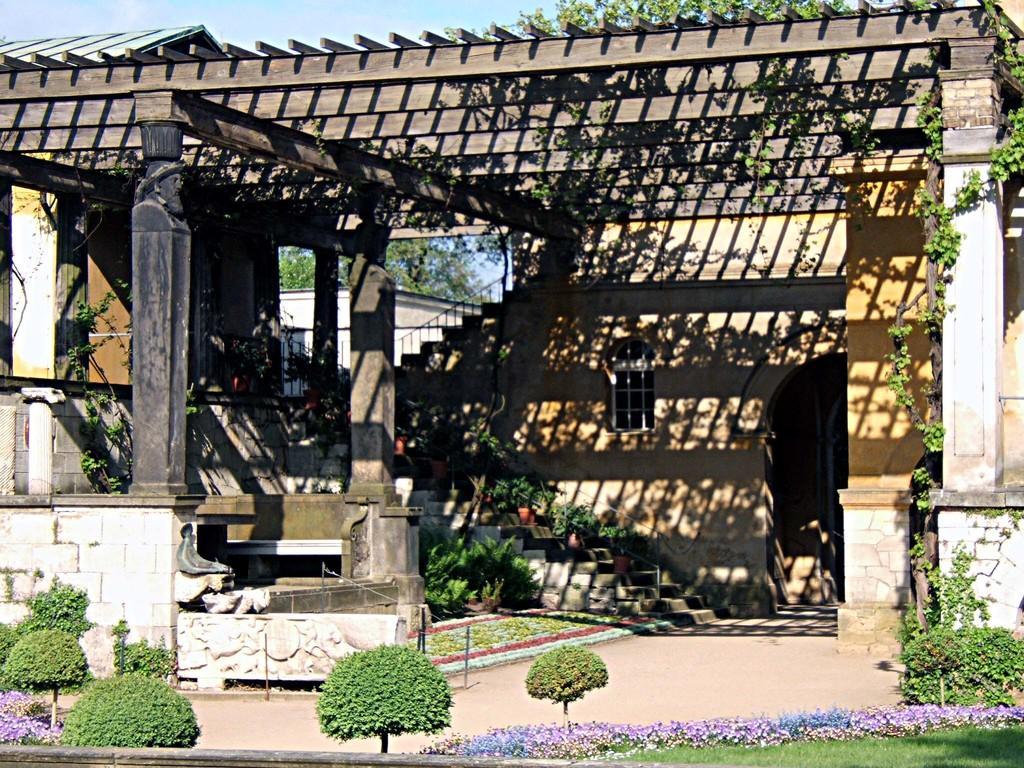In one or two sentences, can you explain what this image depicts? In the foreground of this image, there are flowers, grass and plants at the bottom. In the middle, there is a shelter, wall, stairs, window and an arch. At the top, there is the sky. 